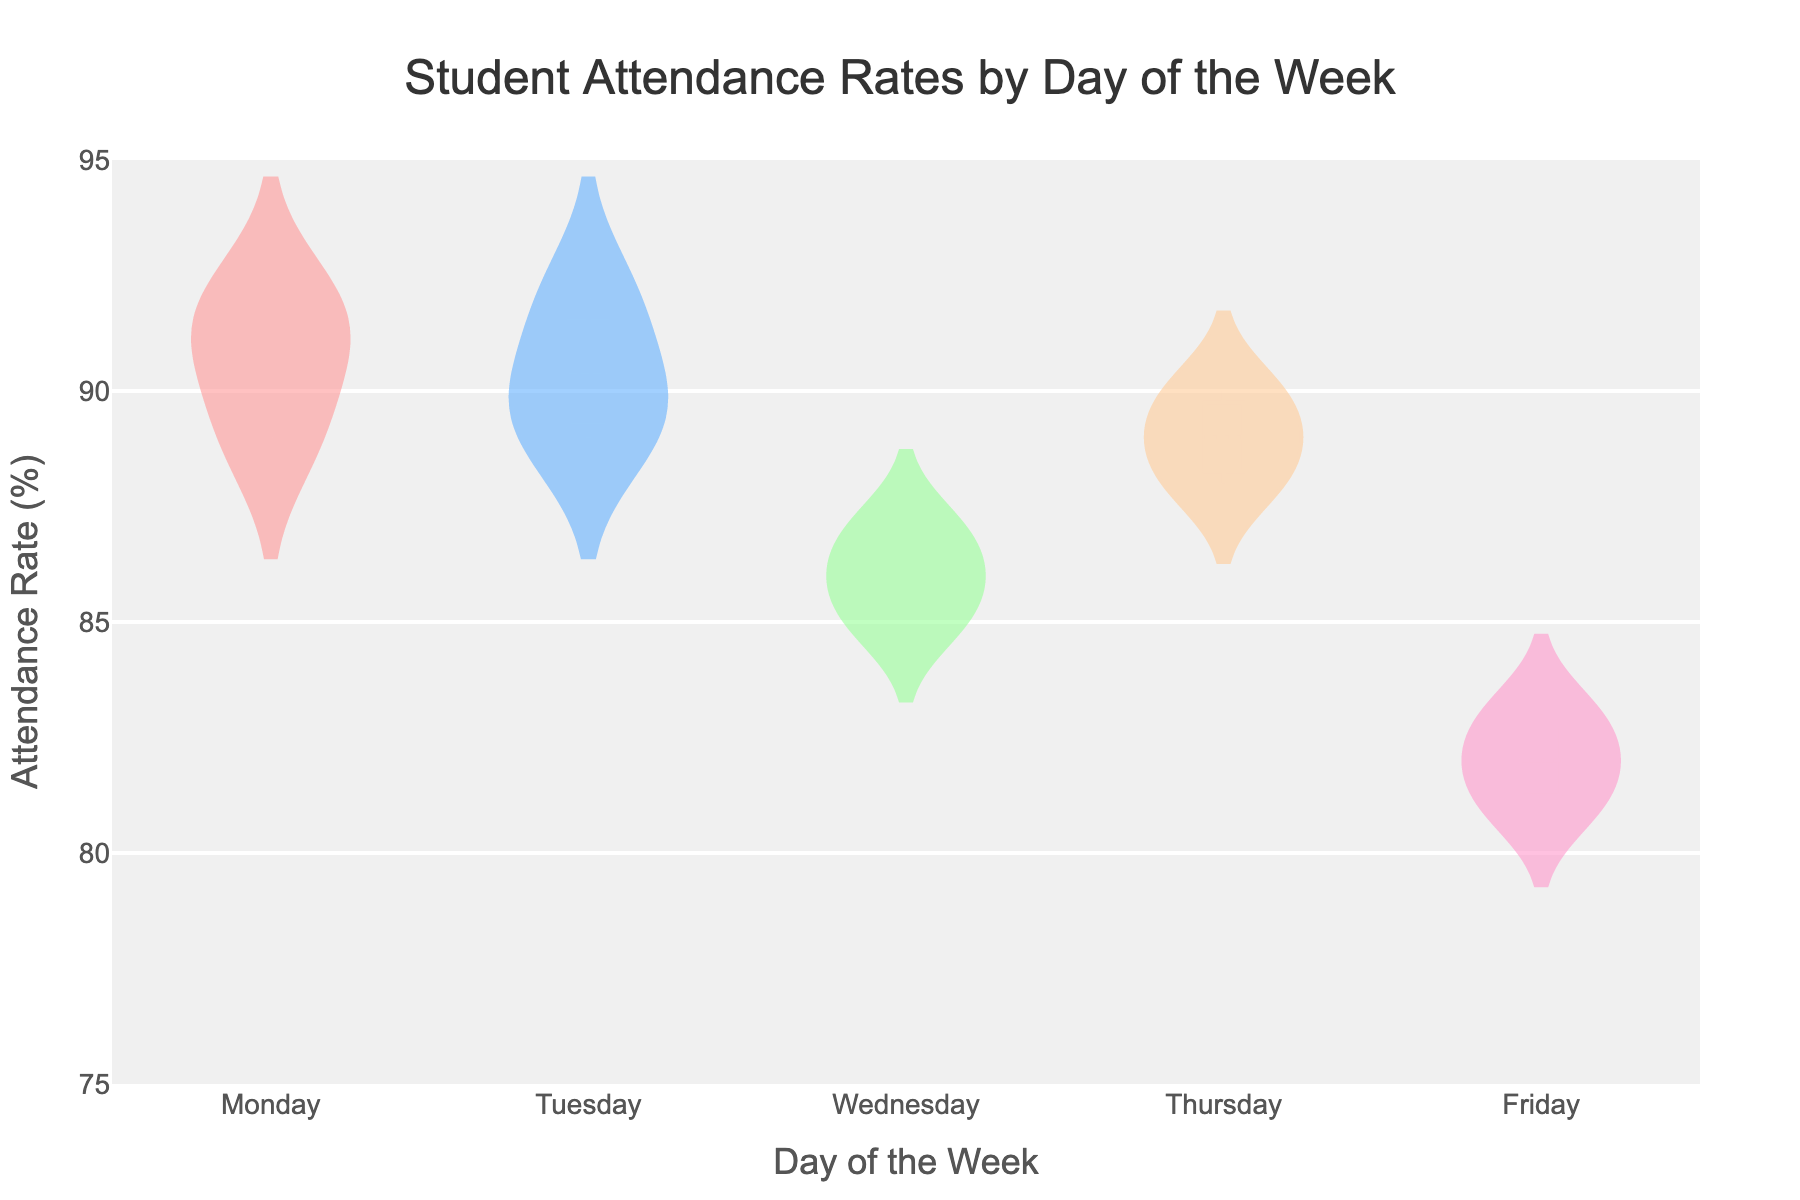What does the title of the plot indicate? The title of the plot is displayed at the top and provides a general summary of what the plot is depicting. In this case, it tells us that the plot represents "Student Attendance Rates by Day of the Week".
Answer: Student Attendance Rates by Day of the Week Which day of the week shows the highest peak attendance rate? By looking at the plot, you can see the highest point of the attendance rates on the y-axis for each day. Monday shows the highest peak at 92%.
Answer: Monday What is the range of attendance rates on Friday? The range of attendance rates can be determined by identifying the minimum and maximum values of the attendance rates displayed for Friday. The lowest value is 81%, and the highest value is 83%.
Answer: 81% to 83% How does the median attendance rate on Tuesday compare to the median attendance rate on Wednesday? The violin plot provides mean lines which can help approximate the median. Tuesday's median appears higher compared to Wednesday's because the central value (middle hinge of the box) is closer to 90% on Tuesday while it is around 86% on Wednesday.
Answer: Tuesday's median is higher Which day has the most variability in student attendance rates? Variability can be inferred by observing the spread of the violin plots. Wednesday has the widest spread of values from 85% to 87%, suggesting it has the most variability.
Answer: Wednesday What is the average attendance rate on Thursday? To find the average attendance rate for Thursday, you sum the attendance rates (88%, 90%, 89%) and divide by the number of data points. (88 + 90 + 89) / 3 = 89%.
Answer: 89% Which day has the lowest minimum attendance rate? To determine the lowest minimum attendance rate, observe the lowest points of the violin plots for each day. Friday has the lowest minimum attendance rate at 81%.
Answer: Friday What is the interquartile range (IQR) for Monday? The interquartile range can be found by subtracting the 25th percentile from the 75th percentile in the violin plot. On Monday, the 25th percentile is roughly around 90% and the 75th percentile is around 92%, so the IQR is 92% - 90% = 2%.
Answer: 2% Between which days is the mean attendance rate nearly the same? The mean lines in the violin plot indicate the mean attendance rate. Monday and Tuesday have mean lines both around 90%, indicating their means are nearly the same.
Answer: Monday and Tuesday Is there a day where the attendance rate never falls below 85%? By examining the lowest points of the violin plots, Monday and Tuesday have the lowest attendance rates above 85%.
Answer: Monday and Tuesday 